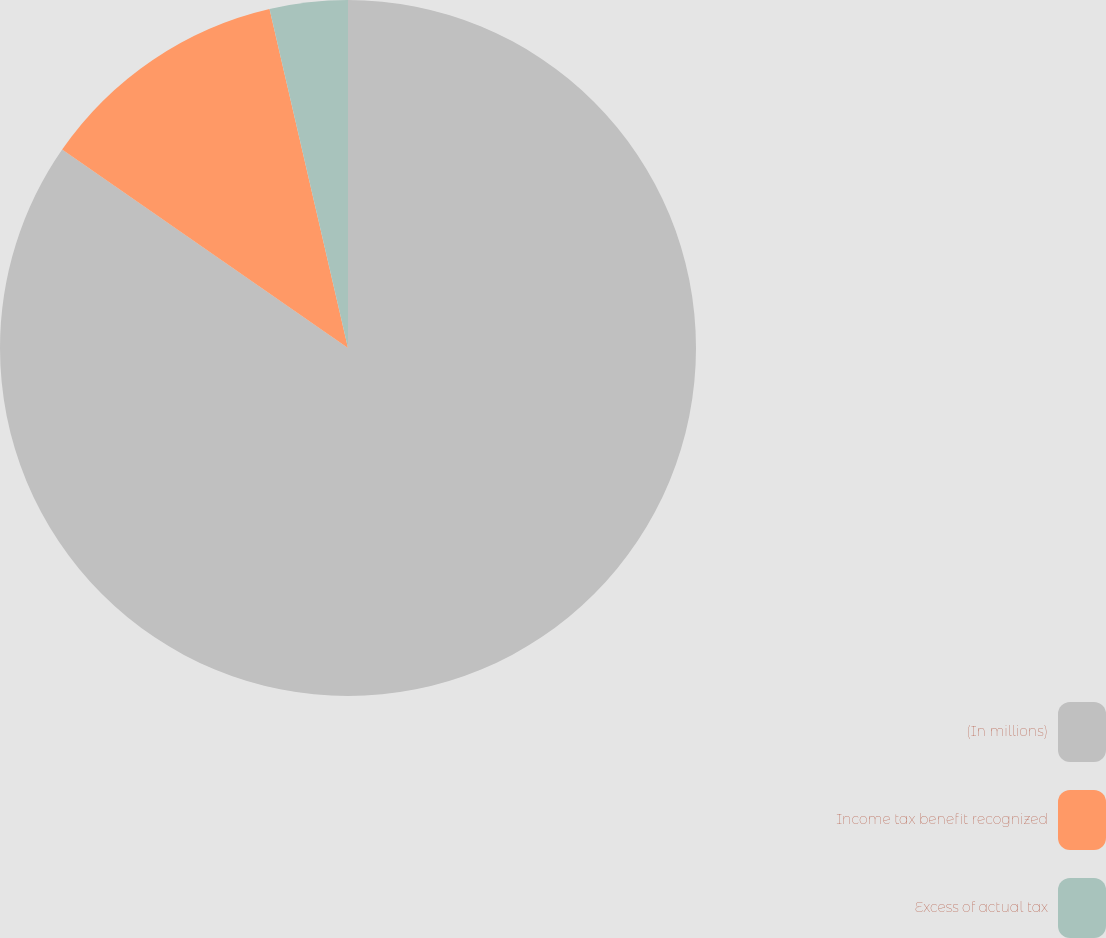Convert chart to OTSL. <chart><loc_0><loc_0><loc_500><loc_500><pie_chart><fcel>(In millions)<fcel>Income tax benefit recognized<fcel>Excess of actual tax<nl><fcel>84.66%<fcel>11.72%<fcel>3.62%<nl></chart> 